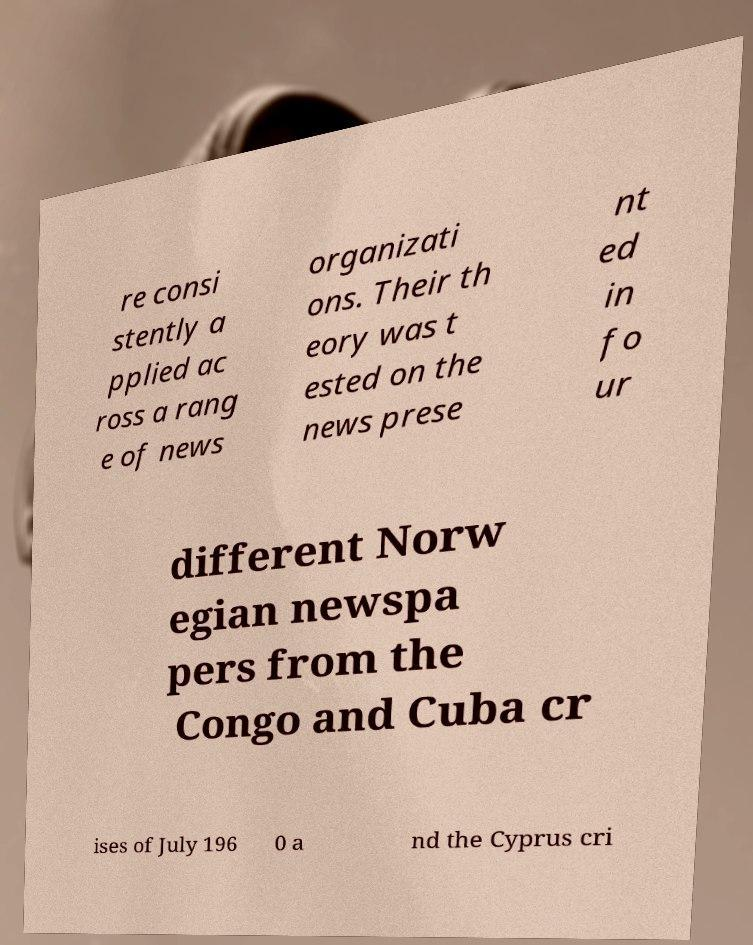I need the written content from this picture converted into text. Can you do that? re consi stently a pplied ac ross a rang e of news organizati ons. Their th eory was t ested on the news prese nt ed in fo ur different Norw egian newspa pers from the Congo and Cuba cr ises of July 196 0 a nd the Cyprus cri 